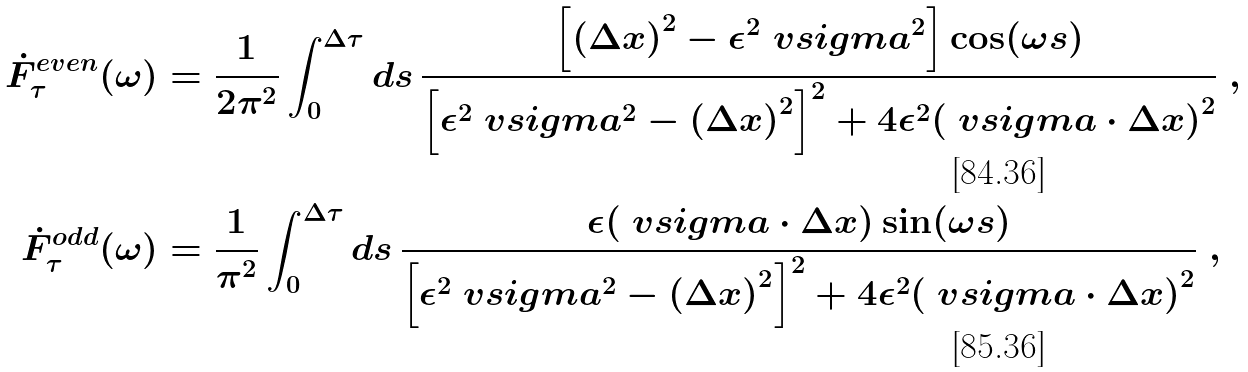<formula> <loc_0><loc_0><loc_500><loc_500>\dot { F } ^ { e v e n } _ { \tau } ( \omega ) & = \frac { 1 } { 2 \pi ^ { 2 } } \int _ { 0 } ^ { \Delta \tau } d s \, \frac { \left [ { ( \Delta x ) } ^ { 2 } - \epsilon ^ { 2 } \ v s i g m a ^ { 2 } \right ] \cos ( \omega s ) } { { \left [ \epsilon ^ { 2 } \ v s i g m a ^ { 2 } - { ( \Delta x ) } ^ { 2 } \right ] } ^ { 2 } + 4 \epsilon ^ { 2 } { ( \ v s i g m a \cdot \Delta x ) } ^ { 2 } } \ , \\ \dot { F } ^ { o d d } _ { \tau } ( \omega ) & = \frac { 1 } { \pi ^ { 2 } } \int _ { 0 } ^ { \Delta \tau } d s \, \frac { \epsilon ( \ v s i g m a \cdot \Delta x ) \sin ( \omega s ) } { { \left [ \epsilon ^ { 2 } \ v s i g m a ^ { 2 } - { ( \Delta x ) } ^ { 2 } \right ] } ^ { 2 } + 4 \epsilon ^ { 2 } { ( \ v s i g m a \cdot \Delta x ) } ^ { 2 } } \ ,</formula> 